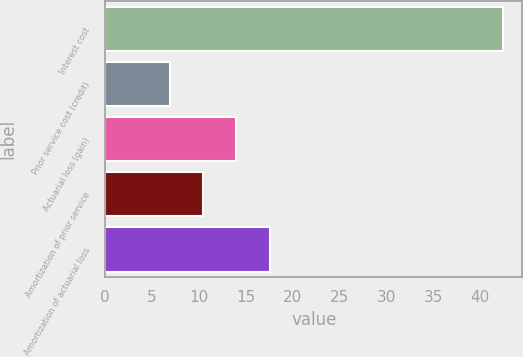<chart> <loc_0><loc_0><loc_500><loc_500><bar_chart><fcel>Interest cost<fcel>Prior service cost (credit)<fcel>Actuarial loss (gain)<fcel>Amortization of prior service<fcel>Amortization of actuarial loss<nl><fcel>42.4<fcel>6.9<fcel>14<fcel>10.45<fcel>17.55<nl></chart> 